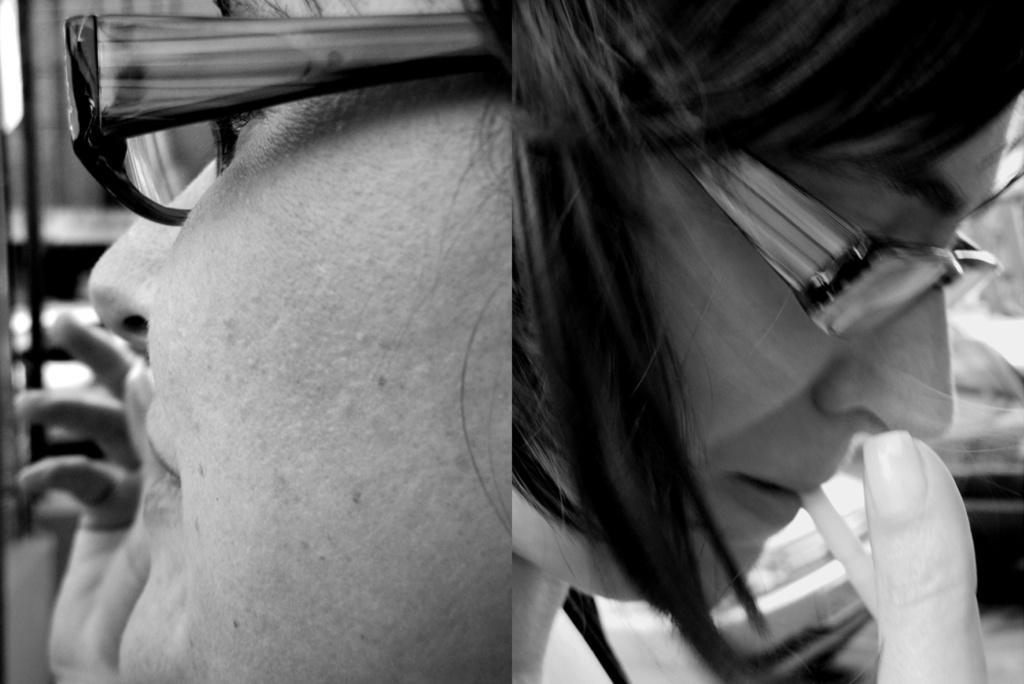Please provide a concise description of this image. In this image I can see a black and white picture which is a collage. I can see two persons wearing spectacles and in the background I can see few vehicles and few other objects. 